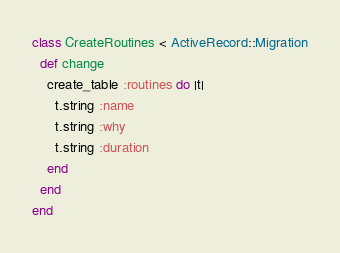Convert code to text. <code><loc_0><loc_0><loc_500><loc_500><_Ruby_>class CreateRoutines < ActiveRecord::Migration
  def change
    create_table :routines do |t| 
      t.string :name 
      t.string :why 
      t.string :duration
    end
  end
end
</code> 